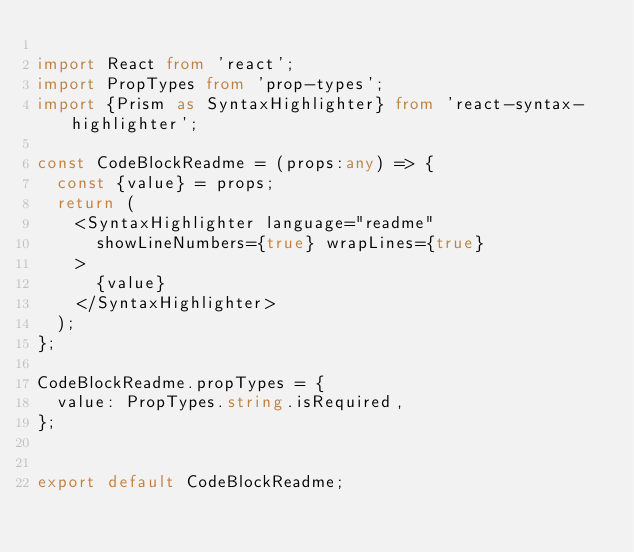<code> <loc_0><loc_0><loc_500><loc_500><_TypeScript_>
import React from 'react';
import PropTypes from 'prop-types';
import {Prism as SyntaxHighlighter} from 'react-syntax-highlighter';

const CodeBlockReadme = (props:any) => {
  const {value} = props;
  return (
    <SyntaxHighlighter language="readme"
      showLineNumbers={true} wrapLines={true}
    >
      {value}
    </SyntaxHighlighter>
  );
};

CodeBlockReadme.propTypes = {
  value: PropTypes.string.isRequired,
};


export default CodeBlockReadme;

</code> 